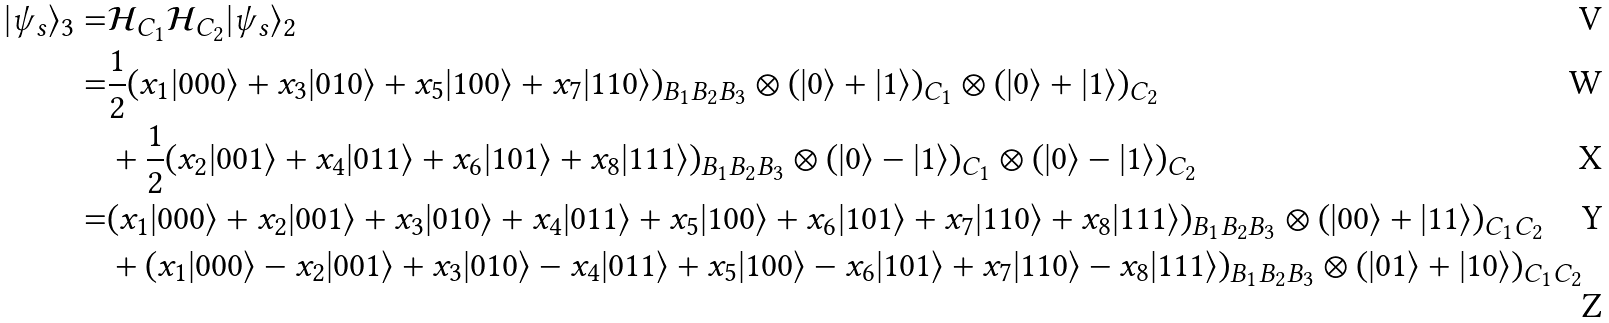<formula> <loc_0><loc_0><loc_500><loc_500>| \psi _ { s } \rangle _ { 3 } = & \mathcal { H } _ { C _ { 1 } } \mathcal { H } _ { C _ { 2 } } | \psi _ { s } \rangle _ { 2 } \\ = & \frac { 1 } { 2 } ( x _ { 1 } | 0 0 0 \rangle + x _ { 3 } | 0 1 0 \rangle + x _ { 5 } | 1 0 0 \rangle + x _ { 7 } | 1 1 0 \rangle ) _ { B _ { 1 } B _ { 2 } B _ { 3 } } \otimes ( | 0 \rangle + | 1 \rangle ) _ { C _ { 1 } } \otimes ( | 0 \rangle + | 1 \rangle ) _ { C _ { 2 } } \\ & + \frac { 1 } { 2 } ( x _ { 2 } | 0 0 1 \rangle + x _ { 4 } | 0 1 1 \rangle + x _ { 6 } | 1 0 1 \rangle + x _ { 8 } | 1 1 1 \rangle ) _ { B _ { 1 } B _ { 2 } B _ { 3 } } \otimes ( | 0 \rangle - | 1 \rangle ) _ { C _ { 1 } } \otimes ( | 0 \rangle - | 1 \rangle ) _ { C _ { 2 } } \\ = & ( x _ { 1 } | 0 0 0 \rangle + x _ { 2 } | 0 0 1 \rangle + x _ { 3 } | 0 1 0 \rangle + x _ { 4 } | 0 1 1 \rangle + x _ { 5 } | 1 0 0 \rangle + x _ { 6 } | 1 0 1 \rangle + x _ { 7 } | 1 1 0 \rangle + x _ { 8 } | 1 1 1 \rangle ) _ { B _ { 1 } B _ { 2 } B _ { 3 } } \otimes ( | 0 0 \rangle + | 1 1 \rangle ) _ { C _ { 1 } C _ { 2 } } \\ & + ( x _ { 1 } | 0 0 0 \rangle - x _ { 2 } | 0 0 1 \rangle + x _ { 3 } | 0 1 0 \rangle - x _ { 4 } | 0 1 1 \rangle + x _ { 5 } | 1 0 0 \rangle - x _ { 6 } | 1 0 1 \rangle + x _ { 7 } | 1 1 0 \rangle - x _ { 8 } | 1 1 1 \rangle ) _ { B _ { 1 } B _ { 2 } B _ { 3 } } \otimes ( | 0 1 \rangle + | 1 0 \rangle ) _ { C _ { 1 } C _ { 2 } }</formula> 